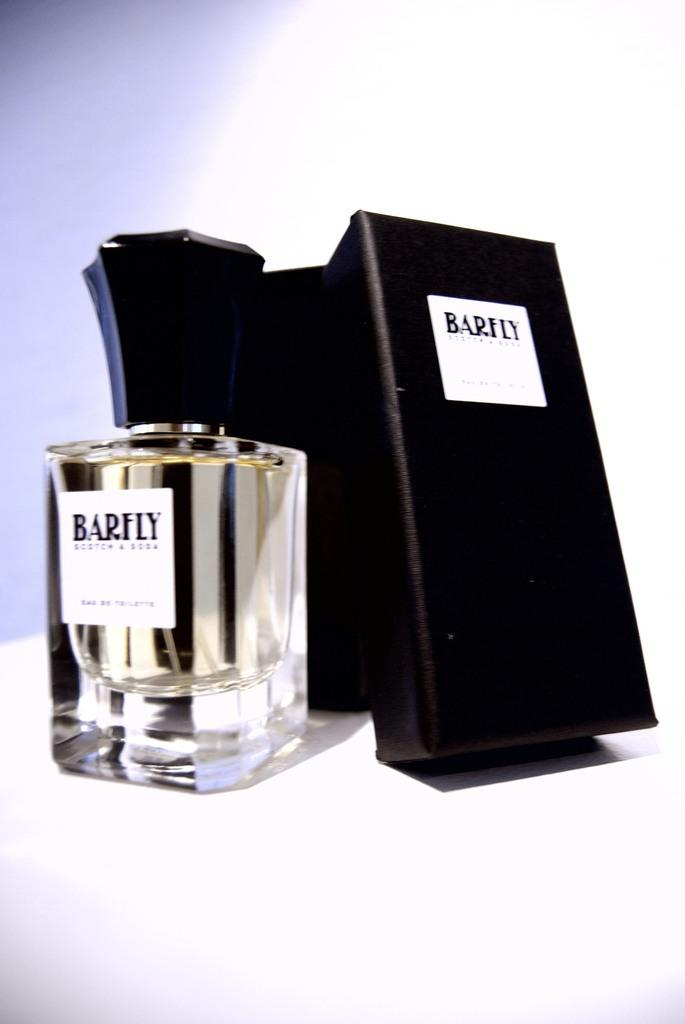Provide a one-sentence caption for the provided image. A display box and glass bottle for Barfly Scotch and Soda. 